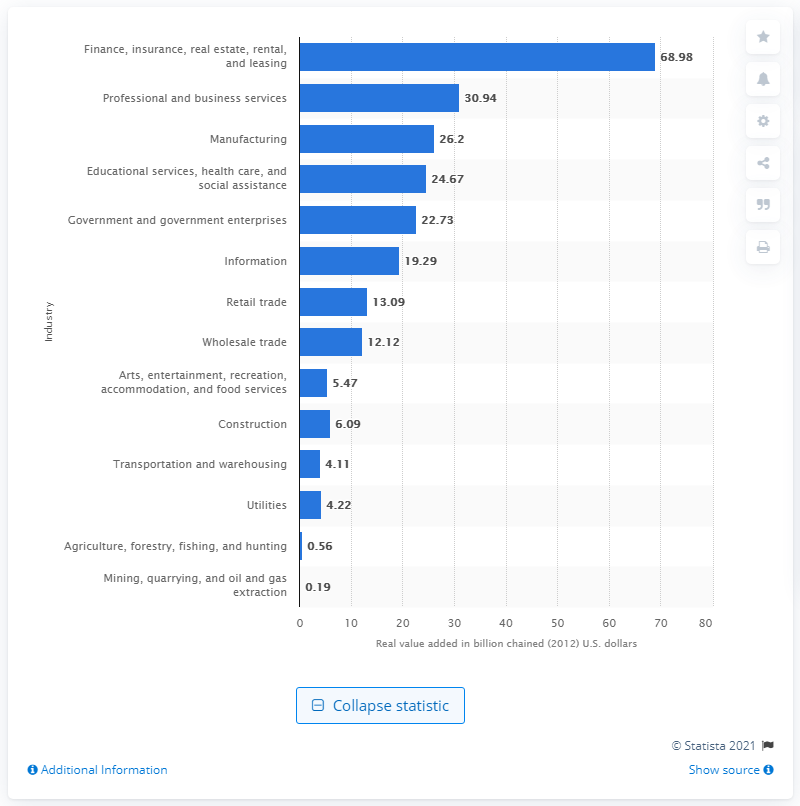Please provide a brief overview of the differences in the contributions of the governmental versus private sectors to Connecticut's GDP. In the chart, we can see that government and government enterprises have a contribution of $22.73 billion, while private industries such as finance, insurance, real estate, rental, and leasing; professional and business services; and manufacturing have significantly higher contributions. This indicates that private industries have a stronger economic impact on Connecticut's GDP compared to government sectors. 